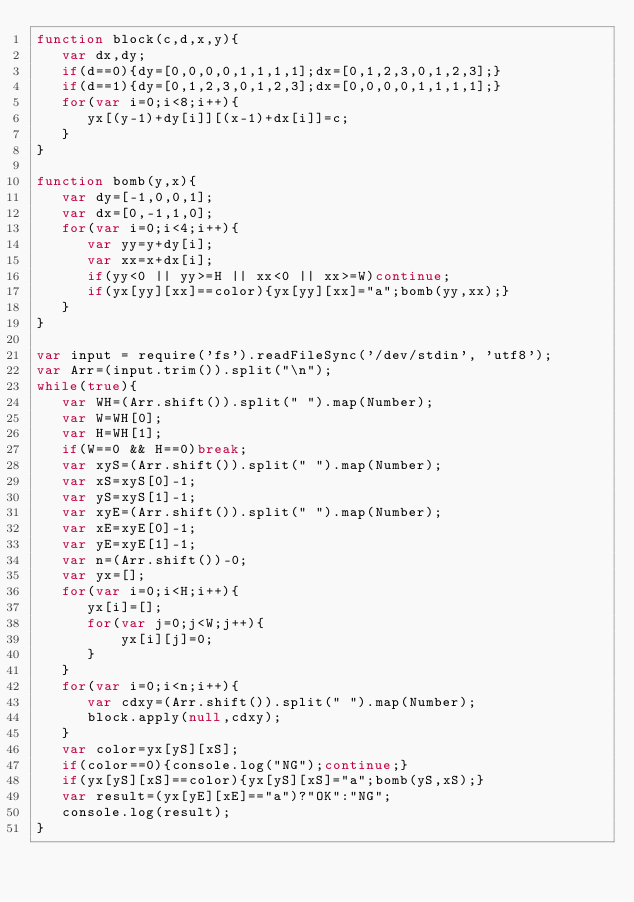Convert code to text. <code><loc_0><loc_0><loc_500><loc_500><_JavaScript_>function block(c,d,x,y){
   var dx,dy;
   if(d==0){dy=[0,0,0,0,1,1,1,1];dx=[0,1,2,3,0,1,2,3];}
   if(d==1){dy=[0,1,2,3,0,1,2,3];dx=[0,0,0,0,1,1,1,1];}
   for(var i=0;i<8;i++){
      yx[(y-1)+dy[i]][(x-1)+dx[i]]=c;
   }
}

function bomb(y,x){
   var dy=[-1,0,0,1];
   var dx=[0,-1,1,0];
   for(var i=0;i<4;i++){
      var yy=y+dy[i];
      var xx=x+dx[i];
      if(yy<0 || yy>=H || xx<0 || xx>=W)continue;
      if(yx[yy][xx]==color){yx[yy][xx]="a";bomb(yy,xx);}
   }
}

var input = require('fs').readFileSync('/dev/stdin', 'utf8');
var Arr=(input.trim()).split("\n");
while(true){
   var WH=(Arr.shift()).split(" ").map(Number);
   var W=WH[0];
   var H=WH[1];
   if(W==0 && H==0)break;
   var xyS=(Arr.shift()).split(" ").map(Number);
   var xS=xyS[0]-1;
   var yS=xyS[1]-1;
   var xyE=(Arr.shift()).split(" ").map(Number);
   var xE=xyE[0]-1;
   var yE=xyE[1]-1;
   var n=(Arr.shift())-0;
   var yx=[];
   for(var i=0;i<H;i++){
      yx[i]=[];
      for(var j=0;j<W;j++){
          yx[i][j]=0;
      }
   }
   for(var i=0;i<n;i++){
      var cdxy=(Arr.shift()).split(" ").map(Number);
      block.apply(null,cdxy);
   }
   var color=yx[yS][xS];
   if(color==0){console.log("NG");continue;}
   if(yx[yS][xS]==color){yx[yS][xS]="a";bomb(yS,xS);}
   var result=(yx[yE][xE]=="a")?"OK":"NG";
   console.log(result);
}</code> 